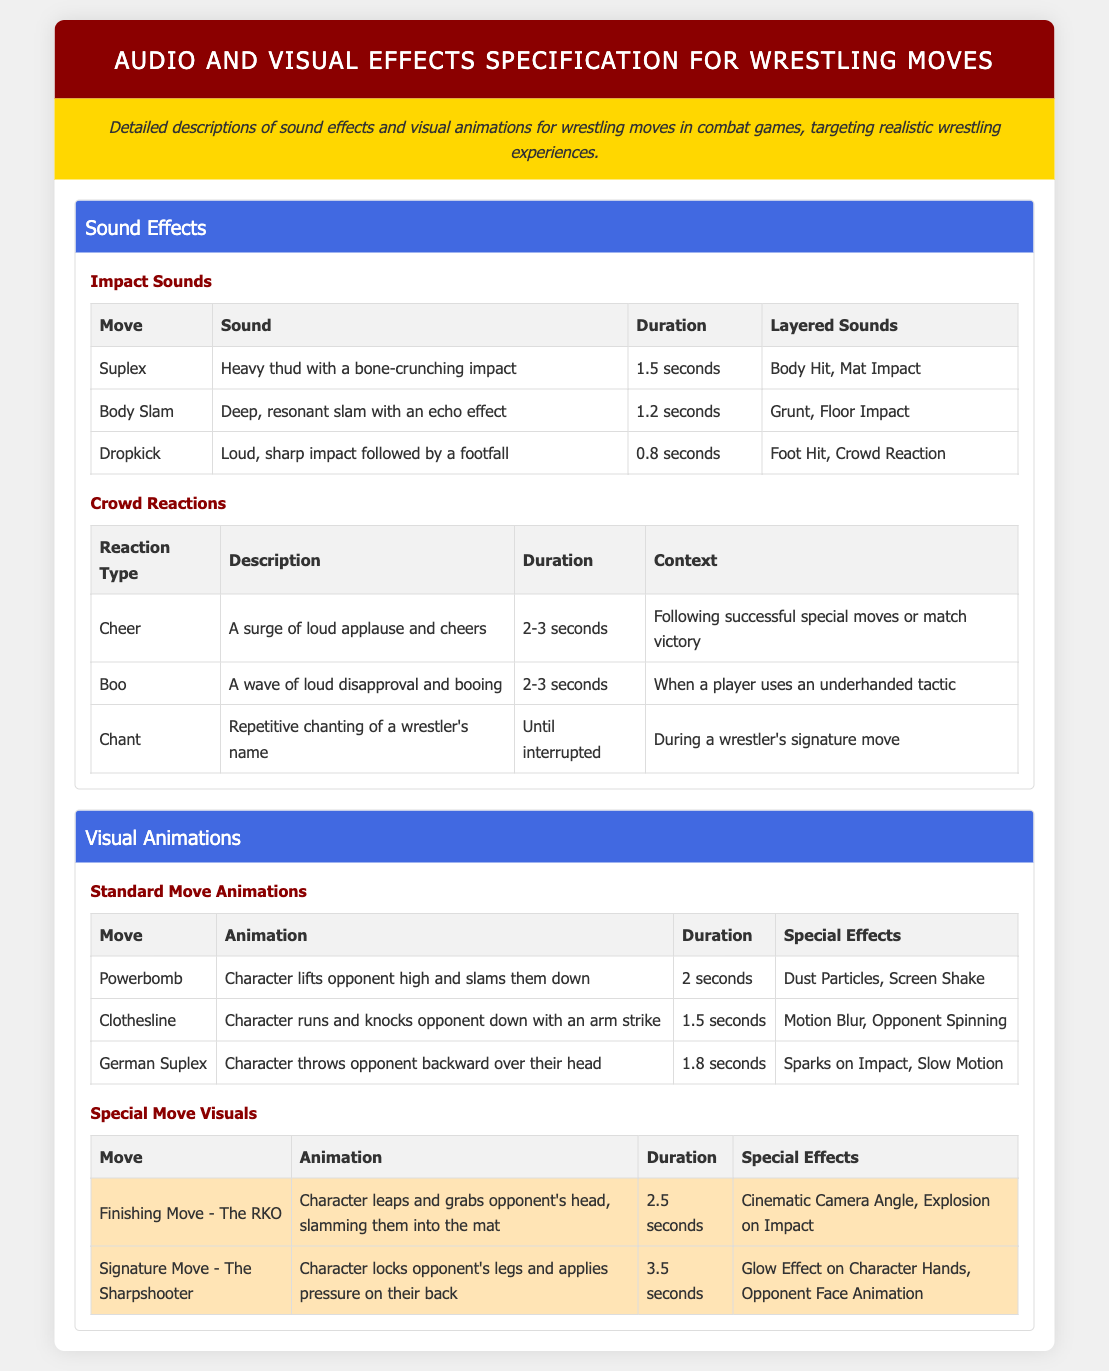What sound accompanies a Suplex? The sound described for a Suplex is a heavy thud with a bone-crunching impact.
Answer: Heavy thud with a bone-crunching impact How long does the crowd cheer last? The duration of the crowd cheer reaction is typically 2-3 seconds.
Answer: 2-3 seconds What special effect is used with the German Suplex? The special effect listed for the German Suplex is sparks on impact.
Answer: Sparks on Impact What is the duration of the Finishing Move - The RKO? The document specifies that the duration of The RKO is 2.5 seconds.
Answer: 2.5 seconds How many layered sounds are there for a Body Slam? The Body Slam has two layered sounds noted: Grunt and Floor Impact.
Answer: Grunt, Floor Impact What is the visual effect used in the Special Move - The Sharpshooter? The visual effect noted for The Sharpshooter includes a glow effect on the character's hands.
Answer: Glow Effect on Character Hands What type of sound is associated with a Dropkick? The sound associated with a Dropkick is a loud, sharp impact followed by a footfall.
Answer: Loud, sharp impact followed by a footfall What happens during the crowd reaction when a player uses an underhanded tactic? The crowd reaction is a wave of loud disapproval and booing when an underhanded tactic is used.
Answer: Boo What is the unique feature of the RKO’s animation? The unique feature of the RKO's animation is a cinematic camera angle.
Answer: Cinematic Camera Angle 